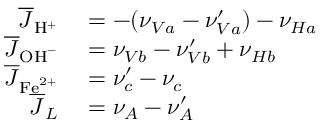<formula> <loc_0><loc_0><loc_500><loc_500>\begin{array} { r l } { \overline { J } _ { H ^ { + } } } & = - ( \nu _ { V a } - \nu _ { V a } ^ { \prime } ) - \nu _ { H a } } \\ { \overline { J } _ { O H ^ { - } } } & = \nu _ { V b } - \nu _ { V b } ^ { \prime } + \nu _ { H b } } \\ { \overline { J } _ { F e ^ { 2 + } } } & = \nu _ { c } ^ { \prime } - \nu _ { c } } \\ { \overline { J } _ { L } } & = \nu _ { A } - \nu _ { A } ^ { \prime } } \end{array}</formula> 